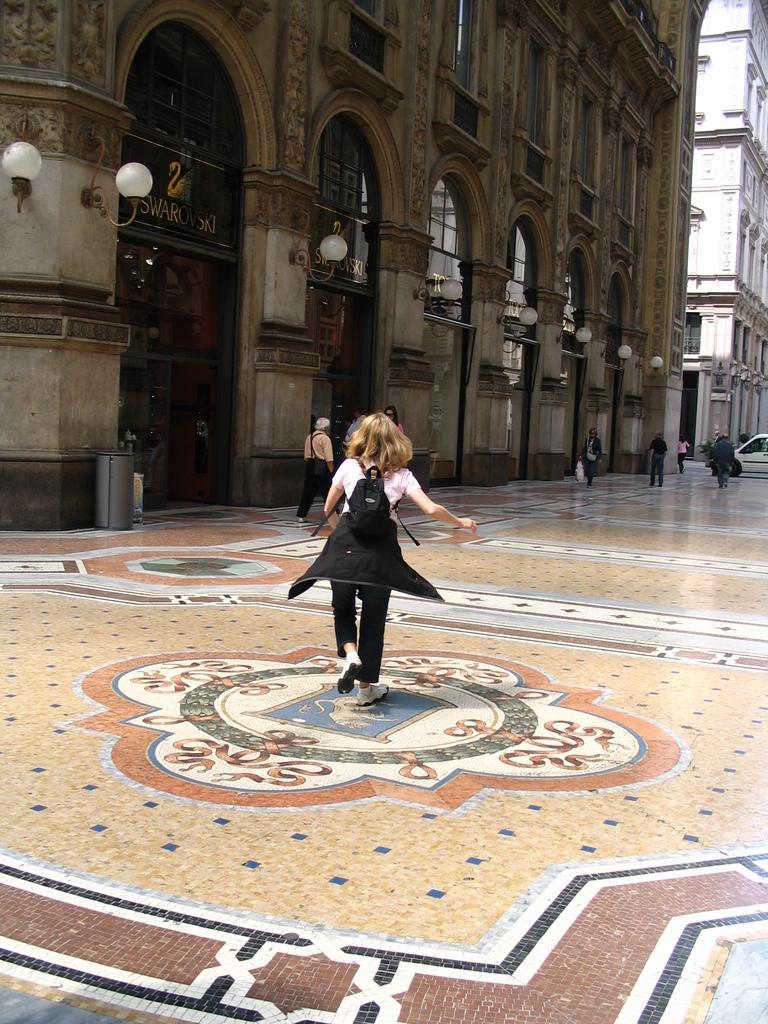Could you give a brief overview of what you see in this image? In this image I can see the group of people with different color dresses. I can see one person wearing the bag. In the background I can see the buildings. There are the lights to the building. I can see the dustbin in-front of the building. In the background I can see the vehicle. 